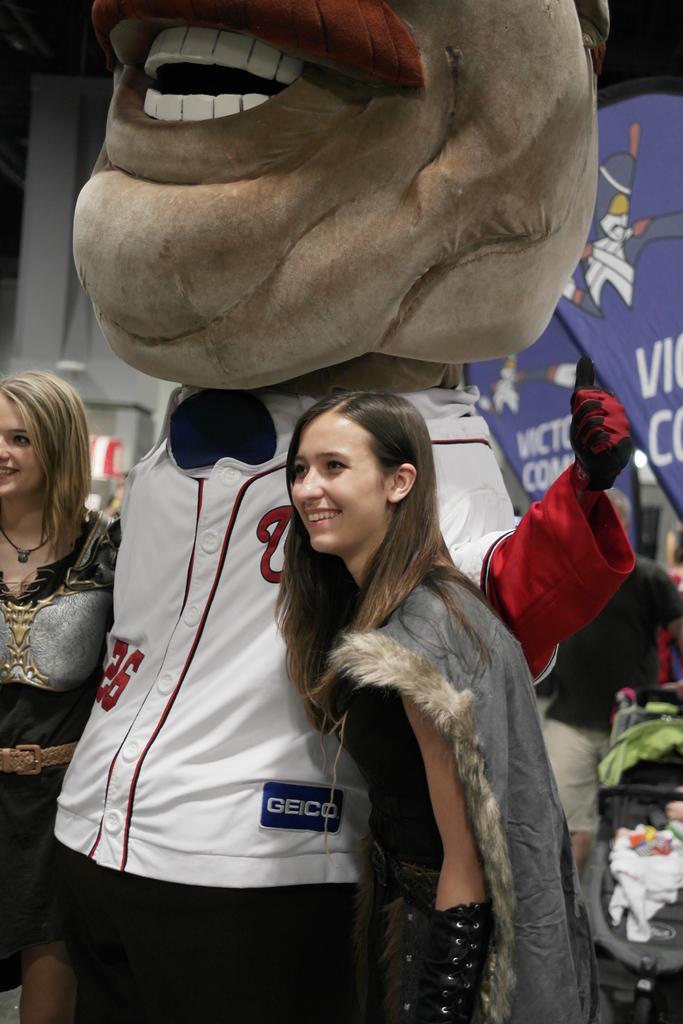What number is one the mascot's jersey?
Your answer should be very brief. 26. 